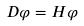<formula> <loc_0><loc_0><loc_500><loc_500>D \varphi = H \varphi</formula> 